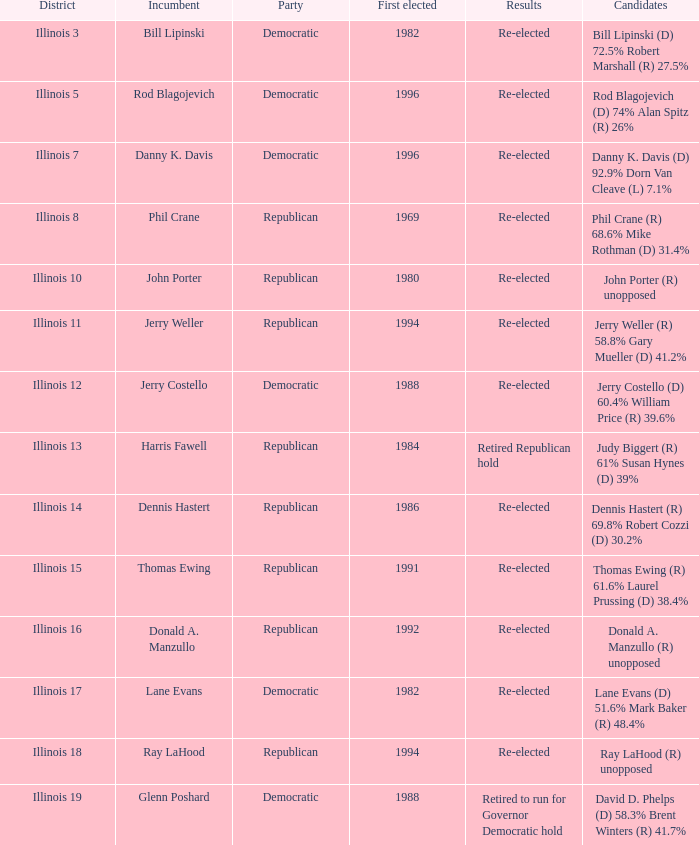What was the outcome in illinois 7? Re-elected. 